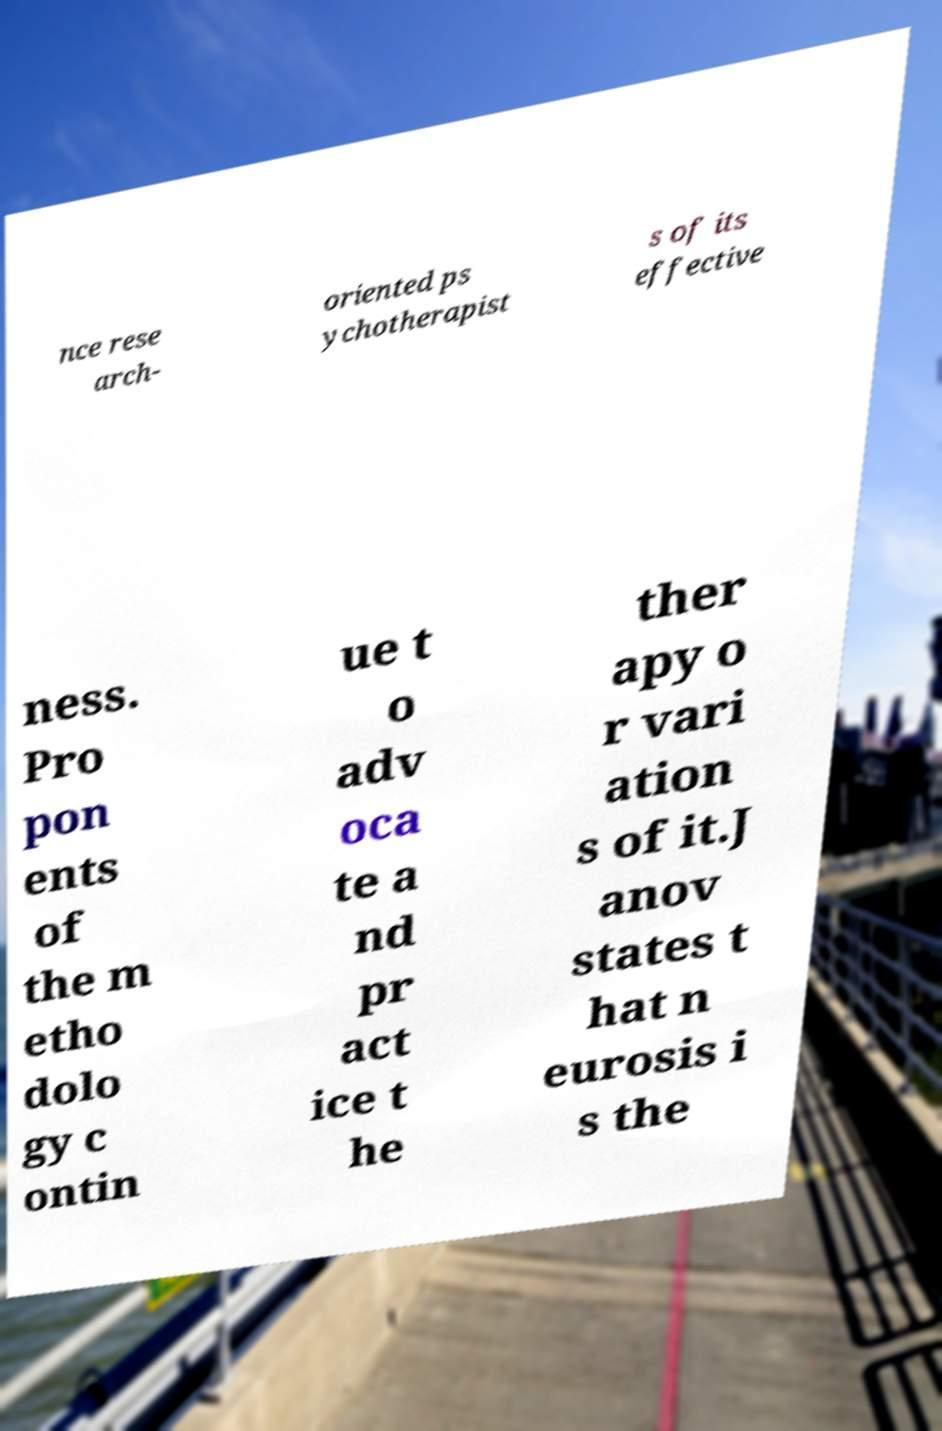Could you extract and type out the text from this image? nce rese arch- oriented ps ychotherapist s of its effective ness. Pro pon ents of the m etho dolo gy c ontin ue t o adv oca te a nd pr act ice t he ther apy o r vari ation s of it.J anov states t hat n eurosis i s the 